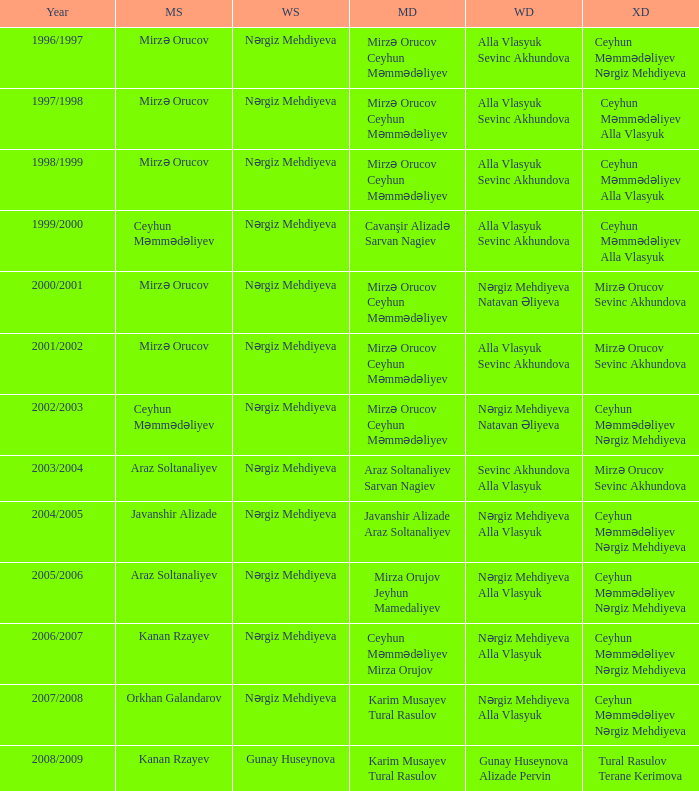Who were all womens doubles for the year 2000/2001? Nərgiz Mehdiyeva Natavan Əliyeva. 